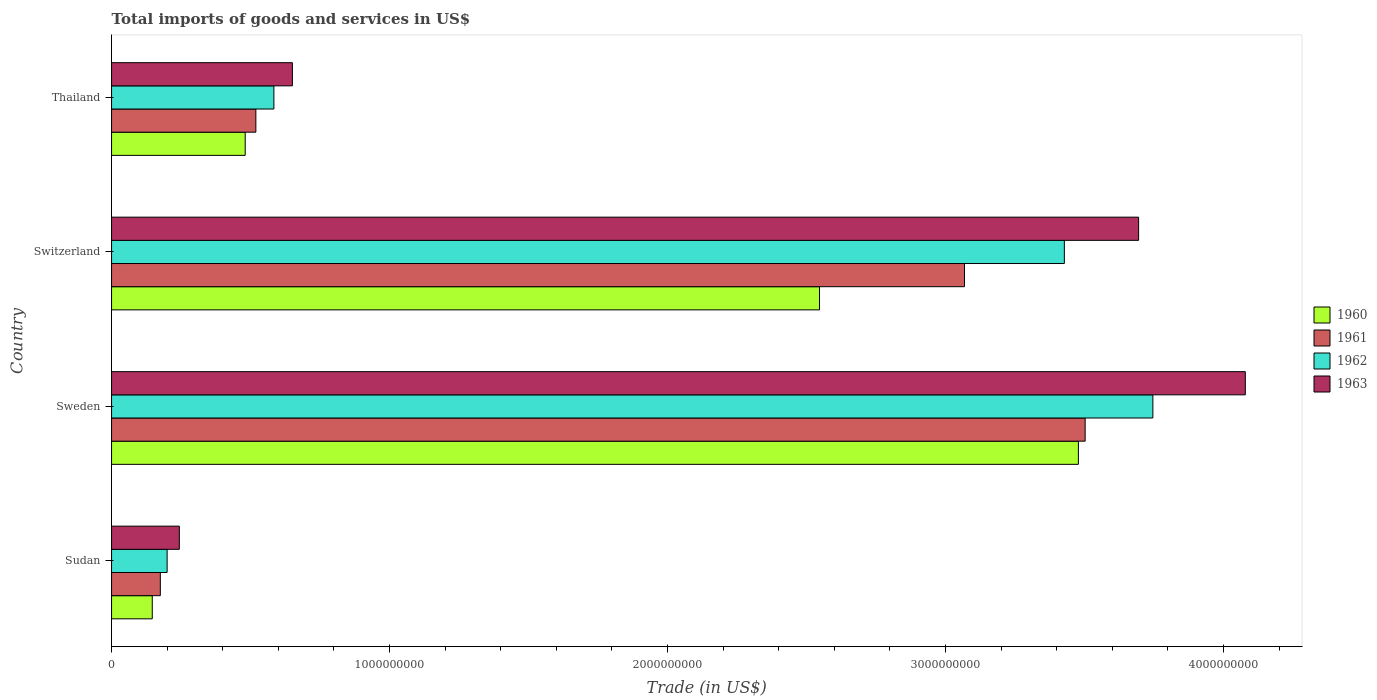How many bars are there on the 2nd tick from the bottom?
Your response must be concise. 4. What is the label of the 1st group of bars from the top?
Your response must be concise. Thailand. What is the total imports of goods and services in 1962 in Thailand?
Offer a terse response. 5.84e+08. Across all countries, what is the maximum total imports of goods and services in 1962?
Your answer should be compact. 3.75e+09. Across all countries, what is the minimum total imports of goods and services in 1963?
Give a very brief answer. 2.44e+08. In which country was the total imports of goods and services in 1960 minimum?
Your response must be concise. Sudan. What is the total total imports of goods and services in 1960 in the graph?
Offer a very short reply. 6.65e+09. What is the difference between the total imports of goods and services in 1961 in Sudan and that in Sweden?
Keep it short and to the point. -3.33e+09. What is the difference between the total imports of goods and services in 1960 in Switzerland and the total imports of goods and services in 1963 in Sudan?
Your answer should be very brief. 2.30e+09. What is the average total imports of goods and services in 1962 per country?
Offer a terse response. 1.99e+09. What is the difference between the total imports of goods and services in 1960 and total imports of goods and services in 1963 in Sweden?
Ensure brevity in your answer.  -6.00e+08. What is the ratio of the total imports of goods and services in 1961 in Sweden to that in Switzerland?
Offer a terse response. 1.14. Is the total imports of goods and services in 1960 in Sweden less than that in Thailand?
Your response must be concise. No. Is the difference between the total imports of goods and services in 1960 in Sweden and Thailand greater than the difference between the total imports of goods and services in 1963 in Sweden and Thailand?
Your answer should be compact. No. What is the difference between the highest and the second highest total imports of goods and services in 1963?
Your answer should be very brief. 3.84e+08. What is the difference between the highest and the lowest total imports of goods and services in 1961?
Offer a very short reply. 3.33e+09. Is the sum of the total imports of goods and services in 1962 in Sweden and Thailand greater than the maximum total imports of goods and services in 1963 across all countries?
Your answer should be compact. Yes. Is it the case that in every country, the sum of the total imports of goods and services in 1962 and total imports of goods and services in 1961 is greater than the sum of total imports of goods and services in 1963 and total imports of goods and services in 1960?
Offer a terse response. No. What does the 2nd bar from the top in Sudan represents?
Make the answer very short. 1962. How many bars are there?
Provide a short and direct response. 16. How many countries are there in the graph?
Keep it short and to the point. 4. Are the values on the major ticks of X-axis written in scientific E-notation?
Offer a very short reply. No. Does the graph contain grids?
Offer a very short reply. No. How are the legend labels stacked?
Your answer should be compact. Vertical. What is the title of the graph?
Offer a terse response. Total imports of goods and services in US$. What is the label or title of the X-axis?
Keep it short and to the point. Trade (in US$). What is the label or title of the Y-axis?
Your answer should be very brief. Country. What is the Trade (in US$) of 1960 in Sudan?
Make the answer very short. 1.46e+08. What is the Trade (in US$) in 1961 in Sudan?
Your response must be concise. 1.75e+08. What is the Trade (in US$) in 1962 in Sudan?
Your answer should be compact. 2.00e+08. What is the Trade (in US$) in 1963 in Sudan?
Provide a succinct answer. 2.44e+08. What is the Trade (in US$) in 1960 in Sweden?
Provide a short and direct response. 3.48e+09. What is the Trade (in US$) of 1961 in Sweden?
Offer a very short reply. 3.50e+09. What is the Trade (in US$) in 1962 in Sweden?
Your response must be concise. 3.75e+09. What is the Trade (in US$) of 1963 in Sweden?
Ensure brevity in your answer.  4.08e+09. What is the Trade (in US$) of 1960 in Switzerland?
Make the answer very short. 2.55e+09. What is the Trade (in US$) of 1961 in Switzerland?
Provide a short and direct response. 3.07e+09. What is the Trade (in US$) of 1962 in Switzerland?
Provide a succinct answer. 3.43e+09. What is the Trade (in US$) in 1963 in Switzerland?
Make the answer very short. 3.69e+09. What is the Trade (in US$) of 1960 in Thailand?
Your answer should be very brief. 4.81e+08. What is the Trade (in US$) of 1961 in Thailand?
Offer a terse response. 5.19e+08. What is the Trade (in US$) of 1962 in Thailand?
Offer a terse response. 5.84e+08. What is the Trade (in US$) in 1963 in Thailand?
Ensure brevity in your answer.  6.51e+08. Across all countries, what is the maximum Trade (in US$) in 1960?
Keep it short and to the point. 3.48e+09. Across all countries, what is the maximum Trade (in US$) in 1961?
Offer a very short reply. 3.50e+09. Across all countries, what is the maximum Trade (in US$) in 1962?
Give a very brief answer. 3.75e+09. Across all countries, what is the maximum Trade (in US$) of 1963?
Keep it short and to the point. 4.08e+09. Across all countries, what is the minimum Trade (in US$) in 1960?
Keep it short and to the point. 1.46e+08. Across all countries, what is the minimum Trade (in US$) of 1961?
Keep it short and to the point. 1.75e+08. Across all countries, what is the minimum Trade (in US$) in 1962?
Your response must be concise. 2.00e+08. Across all countries, what is the minimum Trade (in US$) in 1963?
Provide a short and direct response. 2.44e+08. What is the total Trade (in US$) in 1960 in the graph?
Ensure brevity in your answer.  6.65e+09. What is the total Trade (in US$) of 1961 in the graph?
Ensure brevity in your answer.  7.27e+09. What is the total Trade (in US$) in 1962 in the graph?
Provide a succinct answer. 7.96e+09. What is the total Trade (in US$) of 1963 in the graph?
Your answer should be compact. 8.67e+09. What is the difference between the Trade (in US$) of 1960 in Sudan and that in Sweden?
Your answer should be compact. -3.33e+09. What is the difference between the Trade (in US$) of 1961 in Sudan and that in Sweden?
Provide a succinct answer. -3.33e+09. What is the difference between the Trade (in US$) of 1962 in Sudan and that in Sweden?
Provide a succinct answer. -3.55e+09. What is the difference between the Trade (in US$) of 1963 in Sudan and that in Sweden?
Your answer should be compact. -3.83e+09. What is the difference between the Trade (in US$) of 1960 in Sudan and that in Switzerland?
Your answer should be compact. -2.40e+09. What is the difference between the Trade (in US$) in 1961 in Sudan and that in Switzerland?
Offer a very short reply. -2.89e+09. What is the difference between the Trade (in US$) in 1962 in Sudan and that in Switzerland?
Offer a terse response. -3.23e+09. What is the difference between the Trade (in US$) in 1963 in Sudan and that in Switzerland?
Offer a terse response. -3.45e+09. What is the difference between the Trade (in US$) in 1960 in Sudan and that in Thailand?
Your answer should be very brief. -3.34e+08. What is the difference between the Trade (in US$) of 1961 in Sudan and that in Thailand?
Your response must be concise. -3.44e+08. What is the difference between the Trade (in US$) of 1962 in Sudan and that in Thailand?
Provide a succinct answer. -3.84e+08. What is the difference between the Trade (in US$) of 1963 in Sudan and that in Thailand?
Your answer should be very brief. -4.07e+08. What is the difference between the Trade (in US$) of 1960 in Sweden and that in Switzerland?
Provide a succinct answer. 9.31e+08. What is the difference between the Trade (in US$) of 1961 in Sweden and that in Switzerland?
Provide a succinct answer. 4.34e+08. What is the difference between the Trade (in US$) of 1962 in Sweden and that in Switzerland?
Your answer should be compact. 3.18e+08. What is the difference between the Trade (in US$) of 1963 in Sweden and that in Switzerland?
Offer a terse response. 3.84e+08. What is the difference between the Trade (in US$) of 1960 in Sweden and that in Thailand?
Your response must be concise. 3.00e+09. What is the difference between the Trade (in US$) of 1961 in Sweden and that in Thailand?
Give a very brief answer. 2.98e+09. What is the difference between the Trade (in US$) in 1962 in Sweden and that in Thailand?
Your response must be concise. 3.16e+09. What is the difference between the Trade (in US$) in 1963 in Sweden and that in Thailand?
Offer a very short reply. 3.43e+09. What is the difference between the Trade (in US$) in 1960 in Switzerland and that in Thailand?
Ensure brevity in your answer.  2.07e+09. What is the difference between the Trade (in US$) of 1961 in Switzerland and that in Thailand?
Your answer should be compact. 2.55e+09. What is the difference between the Trade (in US$) in 1962 in Switzerland and that in Thailand?
Keep it short and to the point. 2.84e+09. What is the difference between the Trade (in US$) in 1963 in Switzerland and that in Thailand?
Keep it short and to the point. 3.04e+09. What is the difference between the Trade (in US$) of 1960 in Sudan and the Trade (in US$) of 1961 in Sweden?
Keep it short and to the point. -3.36e+09. What is the difference between the Trade (in US$) of 1960 in Sudan and the Trade (in US$) of 1962 in Sweden?
Make the answer very short. -3.60e+09. What is the difference between the Trade (in US$) of 1960 in Sudan and the Trade (in US$) of 1963 in Sweden?
Your answer should be compact. -3.93e+09. What is the difference between the Trade (in US$) in 1961 in Sudan and the Trade (in US$) in 1962 in Sweden?
Keep it short and to the point. -3.57e+09. What is the difference between the Trade (in US$) in 1961 in Sudan and the Trade (in US$) in 1963 in Sweden?
Your answer should be very brief. -3.90e+09. What is the difference between the Trade (in US$) in 1962 in Sudan and the Trade (in US$) in 1963 in Sweden?
Your answer should be compact. -3.88e+09. What is the difference between the Trade (in US$) in 1960 in Sudan and the Trade (in US$) in 1961 in Switzerland?
Offer a terse response. -2.92e+09. What is the difference between the Trade (in US$) of 1960 in Sudan and the Trade (in US$) of 1962 in Switzerland?
Your answer should be very brief. -3.28e+09. What is the difference between the Trade (in US$) in 1960 in Sudan and the Trade (in US$) in 1963 in Switzerland?
Give a very brief answer. -3.55e+09. What is the difference between the Trade (in US$) in 1961 in Sudan and the Trade (in US$) in 1962 in Switzerland?
Make the answer very short. -3.25e+09. What is the difference between the Trade (in US$) in 1961 in Sudan and the Trade (in US$) in 1963 in Switzerland?
Provide a succinct answer. -3.52e+09. What is the difference between the Trade (in US$) in 1962 in Sudan and the Trade (in US$) in 1963 in Switzerland?
Provide a succinct answer. -3.49e+09. What is the difference between the Trade (in US$) of 1960 in Sudan and the Trade (in US$) of 1961 in Thailand?
Ensure brevity in your answer.  -3.73e+08. What is the difference between the Trade (in US$) of 1960 in Sudan and the Trade (in US$) of 1962 in Thailand?
Provide a succinct answer. -4.38e+08. What is the difference between the Trade (in US$) in 1960 in Sudan and the Trade (in US$) in 1963 in Thailand?
Provide a short and direct response. -5.04e+08. What is the difference between the Trade (in US$) in 1961 in Sudan and the Trade (in US$) in 1962 in Thailand?
Keep it short and to the point. -4.09e+08. What is the difference between the Trade (in US$) of 1961 in Sudan and the Trade (in US$) of 1963 in Thailand?
Offer a terse response. -4.75e+08. What is the difference between the Trade (in US$) in 1962 in Sudan and the Trade (in US$) in 1963 in Thailand?
Offer a very short reply. -4.51e+08. What is the difference between the Trade (in US$) in 1960 in Sweden and the Trade (in US$) in 1961 in Switzerland?
Your answer should be very brief. 4.10e+08. What is the difference between the Trade (in US$) in 1960 in Sweden and the Trade (in US$) in 1962 in Switzerland?
Keep it short and to the point. 5.05e+07. What is the difference between the Trade (in US$) in 1960 in Sweden and the Trade (in US$) in 1963 in Switzerland?
Give a very brief answer. -2.17e+08. What is the difference between the Trade (in US$) of 1961 in Sweden and the Trade (in US$) of 1962 in Switzerland?
Offer a terse response. 7.48e+07. What is the difference between the Trade (in US$) in 1961 in Sweden and the Trade (in US$) in 1963 in Switzerland?
Provide a short and direct response. -1.92e+08. What is the difference between the Trade (in US$) in 1962 in Sweden and the Trade (in US$) in 1963 in Switzerland?
Make the answer very short. 5.13e+07. What is the difference between the Trade (in US$) of 1960 in Sweden and the Trade (in US$) of 1961 in Thailand?
Provide a short and direct response. 2.96e+09. What is the difference between the Trade (in US$) in 1960 in Sweden and the Trade (in US$) in 1962 in Thailand?
Provide a succinct answer. 2.89e+09. What is the difference between the Trade (in US$) in 1960 in Sweden and the Trade (in US$) in 1963 in Thailand?
Provide a short and direct response. 2.83e+09. What is the difference between the Trade (in US$) in 1961 in Sweden and the Trade (in US$) in 1962 in Thailand?
Offer a terse response. 2.92e+09. What is the difference between the Trade (in US$) of 1961 in Sweden and the Trade (in US$) of 1963 in Thailand?
Provide a succinct answer. 2.85e+09. What is the difference between the Trade (in US$) in 1962 in Sweden and the Trade (in US$) in 1963 in Thailand?
Ensure brevity in your answer.  3.10e+09. What is the difference between the Trade (in US$) of 1960 in Switzerland and the Trade (in US$) of 1961 in Thailand?
Provide a short and direct response. 2.03e+09. What is the difference between the Trade (in US$) in 1960 in Switzerland and the Trade (in US$) in 1962 in Thailand?
Ensure brevity in your answer.  1.96e+09. What is the difference between the Trade (in US$) in 1960 in Switzerland and the Trade (in US$) in 1963 in Thailand?
Your answer should be very brief. 1.90e+09. What is the difference between the Trade (in US$) of 1961 in Switzerland and the Trade (in US$) of 1962 in Thailand?
Make the answer very short. 2.48e+09. What is the difference between the Trade (in US$) in 1961 in Switzerland and the Trade (in US$) in 1963 in Thailand?
Give a very brief answer. 2.42e+09. What is the difference between the Trade (in US$) in 1962 in Switzerland and the Trade (in US$) in 1963 in Thailand?
Ensure brevity in your answer.  2.78e+09. What is the average Trade (in US$) of 1960 per country?
Offer a terse response. 1.66e+09. What is the average Trade (in US$) of 1961 per country?
Offer a terse response. 1.82e+09. What is the average Trade (in US$) in 1962 per country?
Keep it short and to the point. 1.99e+09. What is the average Trade (in US$) in 1963 per country?
Give a very brief answer. 2.17e+09. What is the difference between the Trade (in US$) in 1960 and Trade (in US$) in 1961 in Sudan?
Your response must be concise. -2.90e+07. What is the difference between the Trade (in US$) of 1960 and Trade (in US$) of 1962 in Sudan?
Your answer should be compact. -5.34e+07. What is the difference between the Trade (in US$) of 1960 and Trade (in US$) of 1963 in Sudan?
Your answer should be very brief. -9.74e+07. What is the difference between the Trade (in US$) in 1961 and Trade (in US$) in 1962 in Sudan?
Provide a succinct answer. -2.44e+07. What is the difference between the Trade (in US$) in 1961 and Trade (in US$) in 1963 in Sudan?
Ensure brevity in your answer.  -6.84e+07. What is the difference between the Trade (in US$) of 1962 and Trade (in US$) of 1963 in Sudan?
Make the answer very short. -4.39e+07. What is the difference between the Trade (in US$) of 1960 and Trade (in US$) of 1961 in Sweden?
Keep it short and to the point. -2.44e+07. What is the difference between the Trade (in US$) in 1960 and Trade (in US$) in 1962 in Sweden?
Your answer should be very brief. -2.68e+08. What is the difference between the Trade (in US$) in 1960 and Trade (in US$) in 1963 in Sweden?
Keep it short and to the point. -6.00e+08. What is the difference between the Trade (in US$) in 1961 and Trade (in US$) in 1962 in Sweden?
Your answer should be compact. -2.44e+08. What is the difference between the Trade (in US$) in 1961 and Trade (in US$) in 1963 in Sweden?
Offer a terse response. -5.76e+08. What is the difference between the Trade (in US$) in 1962 and Trade (in US$) in 1963 in Sweden?
Provide a short and direct response. -3.33e+08. What is the difference between the Trade (in US$) of 1960 and Trade (in US$) of 1961 in Switzerland?
Ensure brevity in your answer.  -5.22e+08. What is the difference between the Trade (in US$) of 1960 and Trade (in US$) of 1962 in Switzerland?
Ensure brevity in your answer.  -8.81e+08. What is the difference between the Trade (in US$) in 1960 and Trade (in US$) in 1963 in Switzerland?
Make the answer very short. -1.15e+09. What is the difference between the Trade (in US$) in 1961 and Trade (in US$) in 1962 in Switzerland?
Keep it short and to the point. -3.59e+08. What is the difference between the Trade (in US$) in 1961 and Trade (in US$) in 1963 in Switzerland?
Offer a terse response. -6.26e+08. What is the difference between the Trade (in US$) of 1962 and Trade (in US$) of 1963 in Switzerland?
Keep it short and to the point. -2.67e+08. What is the difference between the Trade (in US$) of 1960 and Trade (in US$) of 1961 in Thailand?
Make the answer very short. -3.83e+07. What is the difference between the Trade (in US$) of 1960 and Trade (in US$) of 1962 in Thailand?
Make the answer very short. -1.03e+08. What is the difference between the Trade (in US$) in 1960 and Trade (in US$) in 1963 in Thailand?
Your response must be concise. -1.70e+08. What is the difference between the Trade (in US$) in 1961 and Trade (in US$) in 1962 in Thailand?
Provide a short and direct response. -6.49e+07. What is the difference between the Trade (in US$) of 1961 and Trade (in US$) of 1963 in Thailand?
Provide a succinct answer. -1.31e+08. What is the difference between the Trade (in US$) in 1962 and Trade (in US$) in 1963 in Thailand?
Ensure brevity in your answer.  -6.65e+07. What is the ratio of the Trade (in US$) of 1960 in Sudan to that in Sweden?
Provide a succinct answer. 0.04. What is the ratio of the Trade (in US$) of 1961 in Sudan to that in Sweden?
Offer a terse response. 0.05. What is the ratio of the Trade (in US$) in 1962 in Sudan to that in Sweden?
Make the answer very short. 0.05. What is the ratio of the Trade (in US$) in 1963 in Sudan to that in Sweden?
Your answer should be compact. 0.06. What is the ratio of the Trade (in US$) of 1960 in Sudan to that in Switzerland?
Provide a succinct answer. 0.06. What is the ratio of the Trade (in US$) of 1961 in Sudan to that in Switzerland?
Offer a very short reply. 0.06. What is the ratio of the Trade (in US$) of 1962 in Sudan to that in Switzerland?
Make the answer very short. 0.06. What is the ratio of the Trade (in US$) of 1963 in Sudan to that in Switzerland?
Offer a very short reply. 0.07. What is the ratio of the Trade (in US$) of 1960 in Sudan to that in Thailand?
Give a very brief answer. 0.3. What is the ratio of the Trade (in US$) of 1961 in Sudan to that in Thailand?
Your answer should be compact. 0.34. What is the ratio of the Trade (in US$) in 1962 in Sudan to that in Thailand?
Provide a succinct answer. 0.34. What is the ratio of the Trade (in US$) of 1963 in Sudan to that in Thailand?
Give a very brief answer. 0.37. What is the ratio of the Trade (in US$) of 1960 in Sweden to that in Switzerland?
Your response must be concise. 1.37. What is the ratio of the Trade (in US$) of 1961 in Sweden to that in Switzerland?
Keep it short and to the point. 1.14. What is the ratio of the Trade (in US$) in 1962 in Sweden to that in Switzerland?
Ensure brevity in your answer.  1.09. What is the ratio of the Trade (in US$) in 1963 in Sweden to that in Switzerland?
Keep it short and to the point. 1.1. What is the ratio of the Trade (in US$) of 1960 in Sweden to that in Thailand?
Your answer should be very brief. 7.23. What is the ratio of the Trade (in US$) in 1961 in Sweden to that in Thailand?
Provide a short and direct response. 6.75. What is the ratio of the Trade (in US$) of 1962 in Sweden to that in Thailand?
Keep it short and to the point. 6.41. What is the ratio of the Trade (in US$) in 1963 in Sweden to that in Thailand?
Your answer should be compact. 6.27. What is the ratio of the Trade (in US$) in 1960 in Switzerland to that in Thailand?
Your answer should be compact. 5.3. What is the ratio of the Trade (in US$) in 1961 in Switzerland to that in Thailand?
Provide a short and direct response. 5.91. What is the ratio of the Trade (in US$) in 1962 in Switzerland to that in Thailand?
Your answer should be compact. 5.87. What is the ratio of the Trade (in US$) of 1963 in Switzerland to that in Thailand?
Keep it short and to the point. 5.68. What is the difference between the highest and the second highest Trade (in US$) in 1960?
Keep it short and to the point. 9.31e+08. What is the difference between the highest and the second highest Trade (in US$) in 1961?
Your answer should be compact. 4.34e+08. What is the difference between the highest and the second highest Trade (in US$) in 1962?
Your answer should be very brief. 3.18e+08. What is the difference between the highest and the second highest Trade (in US$) of 1963?
Provide a succinct answer. 3.84e+08. What is the difference between the highest and the lowest Trade (in US$) in 1960?
Give a very brief answer. 3.33e+09. What is the difference between the highest and the lowest Trade (in US$) in 1961?
Your answer should be compact. 3.33e+09. What is the difference between the highest and the lowest Trade (in US$) of 1962?
Your response must be concise. 3.55e+09. What is the difference between the highest and the lowest Trade (in US$) of 1963?
Your response must be concise. 3.83e+09. 